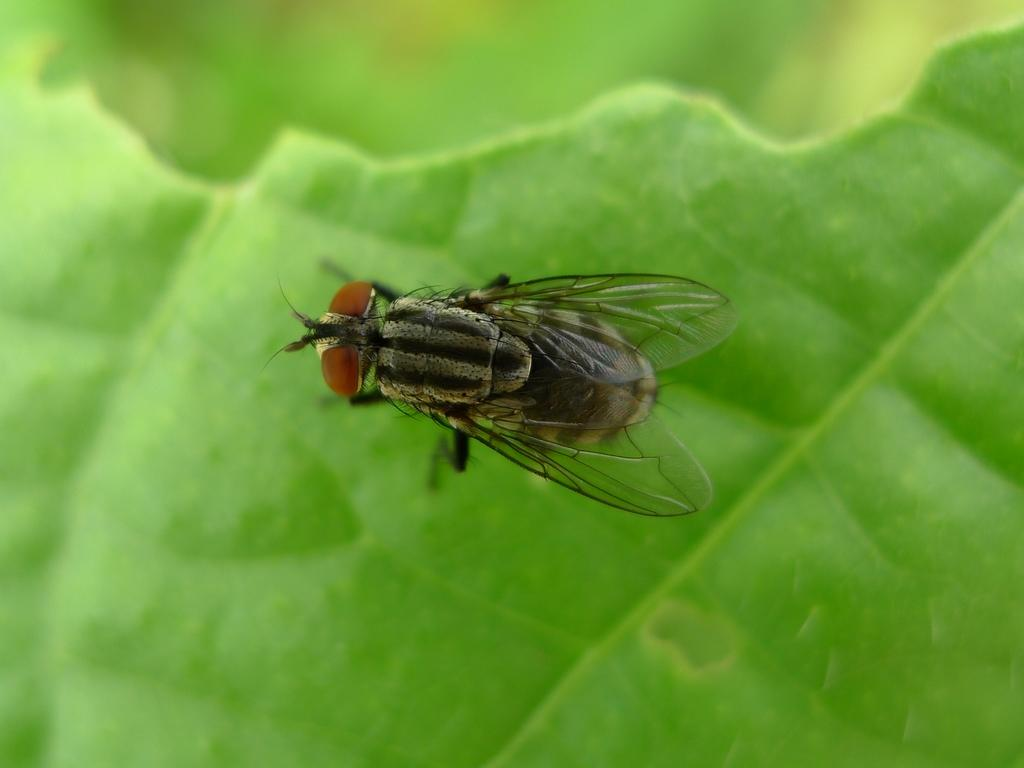What type of insect is present in the image? There is a house fly in the image. Where is the house fly located? The house fly is on a green leaf. What time of day is it in the image, and how does the wrist of the person holding the camera look? The provided facts do not mention the time of day or any person holding a camera, so we cannot determine the time of day or the appearance of a wrist in the image. 